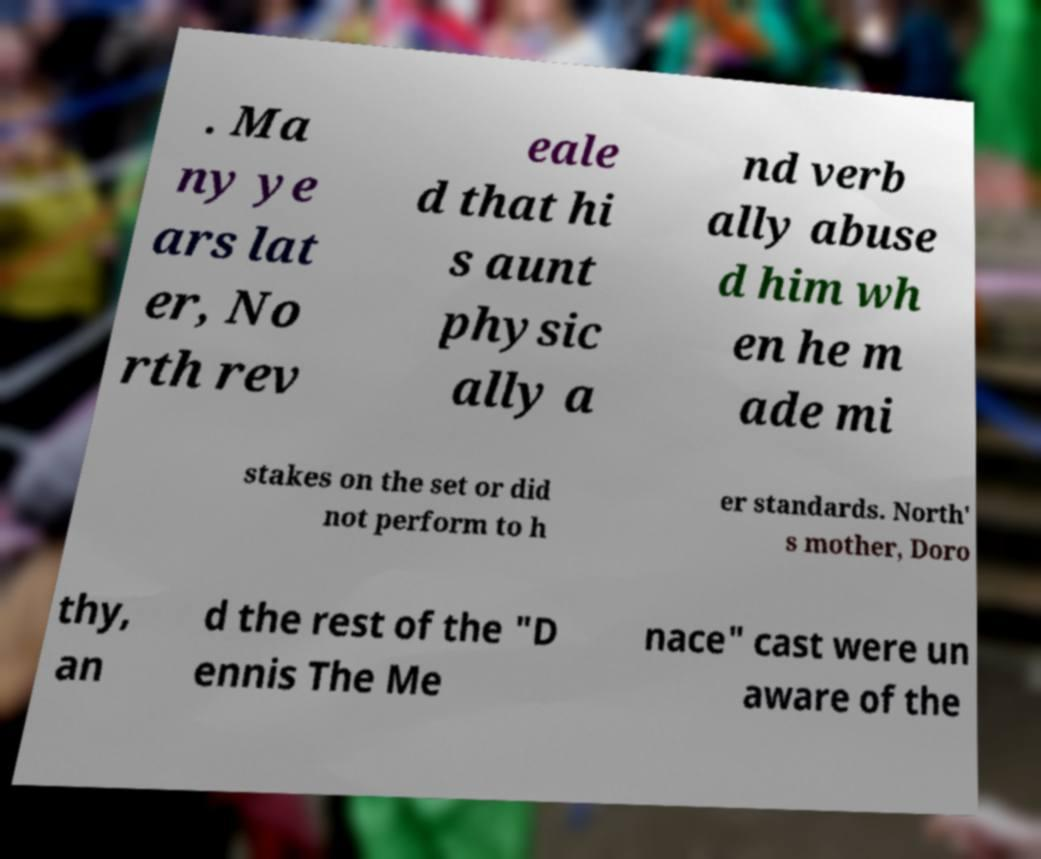Can you accurately transcribe the text from the provided image for me? . Ma ny ye ars lat er, No rth rev eale d that hi s aunt physic ally a nd verb ally abuse d him wh en he m ade mi stakes on the set or did not perform to h er standards. North' s mother, Doro thy, an d the rest of the "D ennis The Me nace" cast were un aware of the 